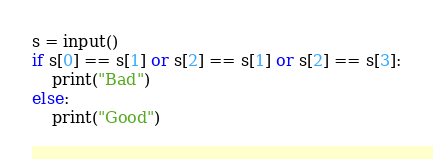<code> <loc_0><loc_0><loc_500><loc_500><_Python_>s = input()
if s[0] == s[1] or s[2] == s[1] or s[2] == s[3]:
    print("Bad")
else:
    print("Good")
</code> 